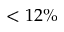Convert formula to latex. <formula><loc_0><loc_0><loc_500><loc_500>< 1 2 \%</formula> 